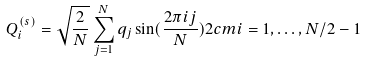Convert formula to latex. <formula><loc_0><loc_0><loc_500><loc_500>Q _ { i } ^ { ( s ) } = \sqrt { \frac { 2 } { N } } \sum _ { j = 1 } ^ { N } q _ { j } \sin ( \frac { 2 \pi i j } { N } ) 2 c m i = 1 , \dots , N / 2 - 1</formula> 